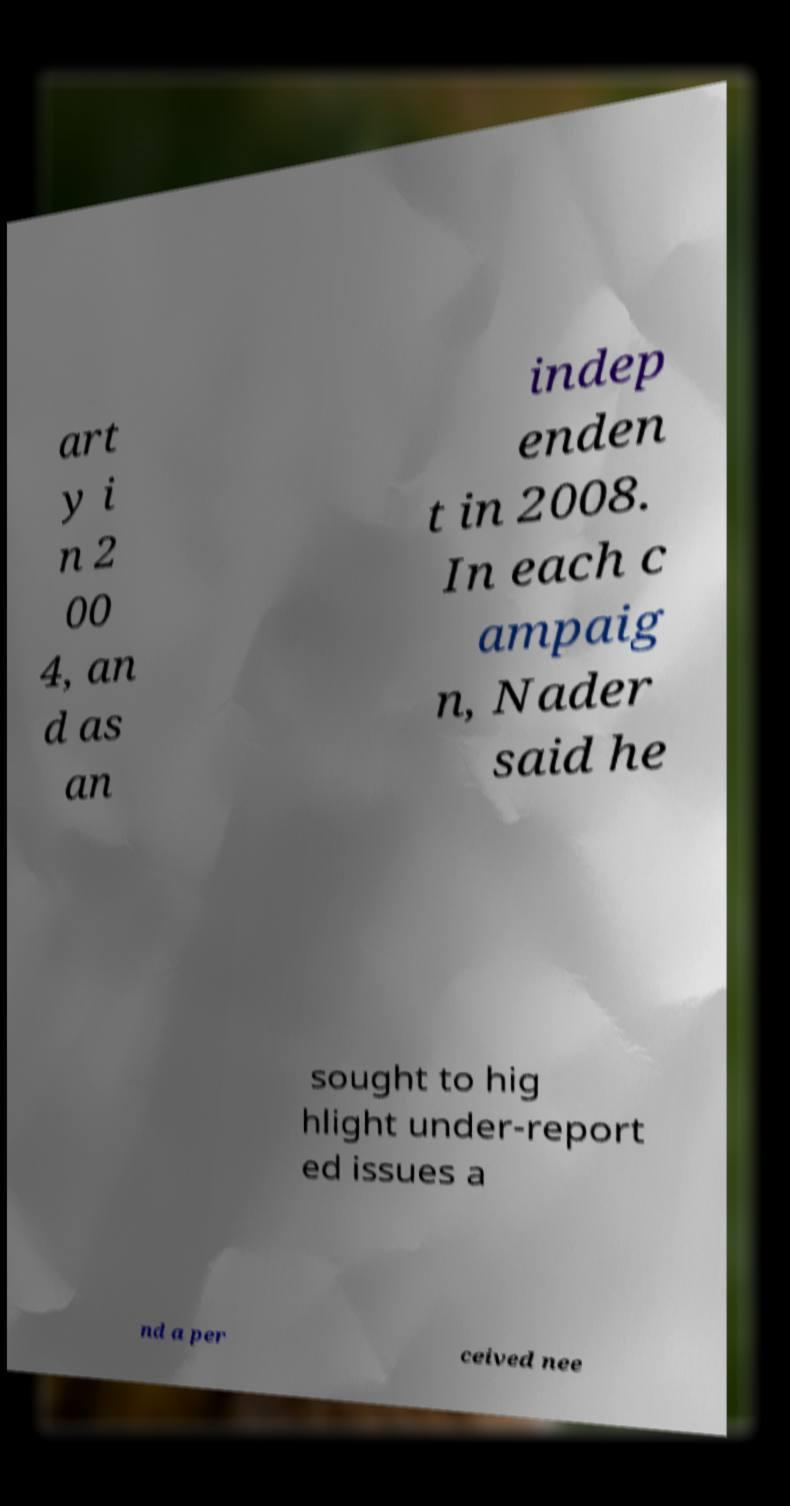Please read and relay the text visible in this image. What does it say? art y i n 2 00 4, an d as an indep enden t in 2008. In each c ampaig n, Nader said he sought to hig hlight under-report ed issues a nd a per ceived nee 